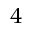Convert formula to latex. <formula><loc_0><loc_0><loc_500><loc_500>^ { 4 }</formula> 